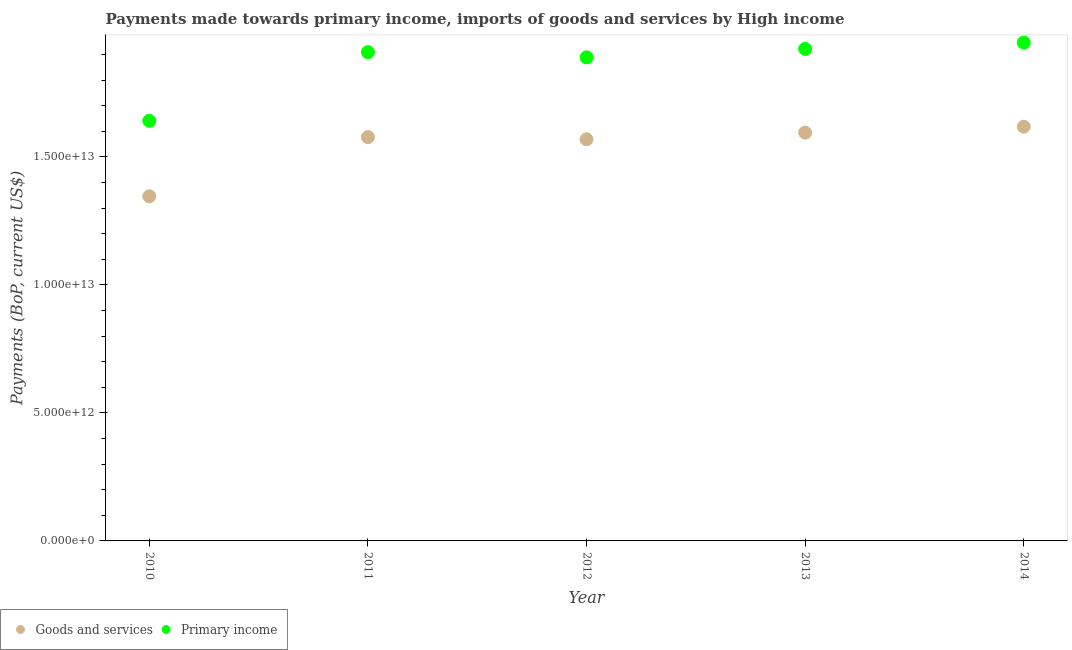How many different coloured dotlines are there?
Offer a terse response. 2. Is the number of dotlines equal to the number of legend labels?
Ensure brevity in your answer.  Yes. What is the payments made towards primary income in 2012?
Provide a short and direct response. 1.89e+13. Across all years, what is the maximum payments made towards goods and services?
Provide a succinct answer. 1.62e+13. Across all years, what is the minimum payments made towards primary income?
Provide a succinct answer. 1.64e+13. In which year was the payments made towards primary income minimum?
Provide a short and direct response. 2010. What is the total payments made towards goods and services in the graph?
Give a very brief answer. 7.70e+13. What is the difference between the payments made towards goods and services in 2012 and that in 2013?
Provide a short and direct response. -2.59e+11. What is the difference between the payments made towards goods and services in 2011 and the payments made towards primary income in 2010?
Make the answer very short. -6.37e+11. What is the average payments made towards goods and services per year?
Make the answer very short. 1.54e+13. In the year 2010, what is the difference between the payments made towards primary income and payments made towards goods and services?
Provide a short and direct response. 2.95e+12. In how many years, is the payments made towards primary income greater than 5000000000000 US$?
Give a very brief answer. 5. What is the ratio of the payments made towards goods and services in 2011 to that in 2013?
Provide a short and direct response. 0.99. Is the payments made towards primary income in 2010 less than that in 2014?
Your response must be concise. Yes. What is the difference between the highest and the second highest payments made towards goods and services?
Keep it short and to the point. 2.32e+11. What is the difference between the highest and the lowest payments made towards goods and services?
Your answer should be compact. 2.72e+12. In how many years, is the payments made towards goods and services greater than the average payments made towards goods and services taken over all years?
Provide a succinct answer. 4. Is the sum of the payments made towards goods and services in 2010 and 2012 greater than the maximum payments made towards primary income across all years?
Provide a succinct answer. Yes. Is the payments made towards primary income strictly greater than the payments made towards goods and services over the years?
Your answer should be very brief. Yes. Is the payments made towards primary income strictly less than the payments made towards goods and services over the years?
Offer a terse response. No. How many dotlines are there?
Provide a short and direct response. 2. How many years are there in the graph?
Your answer should be compact. 5. What is the difference between two consecutive major ticks on the Y-axis?
Your answer should be compact. 5.00e+12. Does the graph contain any zero values?
Offer a very short reply. No. Where does the legend appear in the graph?
Keep it short and to the point. Bottom left. How are the legend labels stacked?
Your answer should be very brief. Horizontal. What is the title of the graph?
Provide a succinct answer. Payments made towards primary income, imports of goods and services by High income. Does "Death rate" appear as one of the legend labels in the graph?
Give a very brief answer. No. What is the label or title of the Y-axis?
Offer a very short reply. Payments (BoP, current US$). What is the Payments (BoP, current US$) in Goods and services in 2010?
Your answer should be very brief. 1.35e+13. What is the Payments (BoP, current US$) of Primary income in 2010?
Make the answer very short. 1.64e+13. What is the Payments (BoP, current US$) of Goods and services in 2011?
Your answer should be very brief. 1.58e+13. What is the Payments (BoP, current US$) in Primary income in 2011?
Provide a succinct answer. 1.91e+13. What is the Payments (BoP, current US$) of Goods and services in 2012?
Ensure brevity in your answer.  1.57e+13. What is the Payments (BoP, current US$) of Primary income in 2012?
Your answer should be compact. 1.89e+13. What is the Payments (BoP, current US$) in Goods and services in 2013?
Make the answer very short. 1.59e+13. What is the Payments (BoP, current US$) of Primary income in 2013?
Your response must be concise. 1.92e+13. What is the Payments (BoP, current US$) of Goods and services in 2014?
Provide a short and direct response. 1.62e+13. What is the Payments (BoP, current US$) of Primary income in 2014?
Your answer should be compact. 1.95e+13. Across all years, what is the maximum Payments (BoP, current US$) of Goods and services?
Provide a short and direct response. 1.62e+13. Across all years, what is the maximum Payments (BoP, current US$) in Primary income?
Your answer should be very brief. 1.95e+13. Across all years, what is the minimum Payments (BoP, current US$) in Goods and services?
Give a very brief answer. 1.35e+13. Across all years, what is the minimum Payments (BoP, current US$) in Primary income?
Your answer should be compact. 1.64e+13. What is the total Payments (BoP, current US$) of Goods and services in the graph?
Give a very brief answer. 7.70e+13. What is the total Payments (BoP, current US$) of Primary income in the graph?
Keep it short and to the point. 9.31e+13. What is the difference between the Payments (BoP, current US$) in Goods and services in 2010 and that in 2011?
Make the answer very short. -2.31e+12. What is the difference between the Payments (BoP, current US$) of Primary income in 2010 and that in 2011?
Give a very brief answer. -2.68e+12. What is the difference between the Payments (BoP, current US$) of Goods and services in 2010 and that in 2012?
Offer a terse response. -2.23e+12. What is the difference between the Payments (BoP, current US$) of Primary income in 2010 and that in 2012?
Ensure brevity in your answer.  -2.48e+12. What is the difference between the Payments (BoP, current US$) in Goods and services in 2010 and that in 2013?
Your answer should be compact. -2.49e+12. What is the difference between the Payments (BoP, current US$) in Primary income in 2010 and that in 2013?
Your answer should be compact. -2.81e+12. What is the difference between the Payments (BoP, current US$) in Goods and services in 2010 and that in 2014?
Provide a succinct answer. -2.72e+12. What is the difference between the Payments (BoP, current US$) of Primary income in 2010 and that in 2014?
Offer a terse response. -3.06e+12. What is the difference between the Payments (BoP, current US$) in Goods and services in 2011 and that in 2012?
Make the answer very short. 8.41e+1. What is the difference between the Payments (BoP, current US$) in Primary income in 2011 and that in 2012?
Provide a succinct answer. 2.03e+11. What is the difference between the Payments (BoP, current US$) in Goods and services in 2011 and that in 2013?
Ensure brevity in your answer.  -1.75e+11. What is the difference between the Payments (BoP, current US$) in Primary income in 2011 and that in 2013?
Make the answer very short. -1.29e+11. What is the difference between the Payments (BoP, current US$) in Goods and services in 2011 and that in 2014?
Provide a succinct answer. -4.07e+11. What is the difference between the Payments (BoP, current US$) of Primary income in 2011 and that in 2014?
Your response must be concise. -3.76e+11. What is the difference between the Payments (BoP, current US$) of Goods and services in 2012 and that in 2013?
Your answer should be compact. -2.59e+11. What is the difference between the Payments (BoP, current US$) in Primary income in 2012 and that in 2013?
Offer a very short reply. -3.32e+11. What is the difference between the Payments (BoP, current US$) of Goods and services in 2012 and that in 2014?
Provide a succinct answer. -4.91e+11. What is the difference between the Payments (BoP, current US$) of Primary income in 2012 and that in 2014?
Make the answer very short. -5.79e+11. What is the difference between the Payments (BoP, current US$) of Goods and services in 2013 and that in 2014?
Your response must be concise. -2.32e+11. What is the difference between the Payments (BoP, current US$) of Primary income in 2013 and that in 2014?
Offer a terse response. -2.47e+11. What is the difference between the Payments (BoP, current US$) of Goods and services in 2010 and the Payments (BoP, current US$) of Primary income in 2011?
Keep it short and to the point. -5.63e+12. What is the difference between the Payments (BoP, current US$) of Goods and services in 2010 and the Payments (BoP, current US$) of Primary income in 2012?
Keep it short and to the point. -5.42e+12. What is the difference between the Payments (BoP, current US$) in Goods and services in 2010 and the Payments (BoP, current US$) in Primary income in 2013?
Make the answer very short. -5.76e+12. What is the difference between the Payments (BoP, current US$) of Goods and services in 2010 and the Payments (BoP, current US$) of Primary income in 2014?
Ensure brevity in your answer.  -6.00e+12. What is the difference between the Payments (BoP, current US$) in Goods and services in 2011 and the Payments (BoP, current US$) in Primary income in 2012?
Offer a very short reply. -3.11e+12. What is the difference between the Payments (BoP, current US$) of Goods and services in 2011 and the Payments (BoP, current US$) of Primary income in 2013?
Provide a short and direct response. -3.45e+12. What is the difference between the Payments (BoP, current US$) of Goods and services in 2011 and the Payments (BoP, current US$) of Primary income in 2014?
Keep it short and to the point. -3.69e+12. What is the difference between the Payments (BoP, current US$) of Goods and services in 2012 and the Payments (BoP, current US$) of Primary income in 2013?
Your answer should be very brief. -3.53e+12. What is the difference between the Payments (BoP, current US$) of Goods and services in 2012 and the Payments (BoP, current US$) of Primary income in 2014?
Provide a succinct answer. -3.78e+12. What is the difference between the Payments (BoP, current US$) of Goods and services in 2013 and the Payments (BoP, current US$) of Primary income in 2014?
Keep it short and to the point. -3.52e+12. What is the average Payments (BoP, current US$) of Goods and services per year?
Make the answer very short. 1.54e+13. What is the average Payments (BoP, current US$) of Primary income per year?
Keep it short and to the point. 1.86e+13. In the year 2010, what is the difference between the Payments (BoP, current US$) in Goods and services and Payments (BoP, current US$) in Primary income?
Give a very brief answer. -2.95e+12. In the year 2011, what is the difference between the Payments (BoP, current US$) of Goods and services and Payments (BoP, current US$) of Primary income?
Your answer should be compact. -3.32e+12. In the year 2012, what is the difference between the Payments (BoP, current US$) of Goods and services and Payments (BoP, current US$) of Primary income?
Provide a succinct answer. -3.20e+12. In the year 2013, what is the difference between the Payments (BoP, current US$) in Goods and services and Payments (BoP, current US$) in Primary income?
Give a very brief answer. -3.27e+12. In the year 2014, what is the difference between the Payments (BoP, current US$) in Goods and services and Payments (BoP, current US$) in Primary income?
Keep it short and to the point. -3.29e+12. What is the ratio of the Payments (BoP, current US$) of Goods and services in 2010 to that in 2011?
Keep it short and to the point. 0.85. What is the ratio of the Payments (BoP, current US$) in Primary income in 2010 to that in 2011?
Offer a very short reply. 0.86. What is the ratio of the Payments (BoP, current US$) of Goods and services in 2010 to that in 2012?
Your answer should be very brief. 0.86. What is the ratio of the Payments (BoP, current US$) in Primary income in 2010 to that in 2012?
Provide a succinct answer. 0.87. What is the ratio of the Payments (BoP, current US$) in Goods and services in 2010 to that in 2013?
Give a very brief answer. 0.84. What is the ratio of the Payments (BoP, current US$) of Primary income in 2010 to that in 2013?
Ensure brevity in your answer.  0.85. What is the ratio of the Payments (BoP, current US$) in Goods and services in 2010 to that in 2014?
Your answer should be compact. 0.83. What is the ratio of the Payments (BoP, current US$) in Primary income in 2010 to that in 2014?
Give a very brief answer. 0.84. What is the ratio of the Payments (BoP, current US$) of Goods and services in 2011 to that in 2012?
Offer a very short reply. 1.01. What is the ratio of the Payments (BoP, current US$) in Primary income in 2011 to that in 2012?
Ensure brevity in your answer.  1.01. What is the ratio of the Payments (BoP, current US$) of Primary income in 2011 to that in 2013?
Provide a short and direct response. 0.99. What is the ratio of the Payments (BoP, current US$) in Goods and services in 2011 to that in 2014?
Keep it short and to the point. 0.97. What is the ratio of the Payments (BoP, current US$) in Primary income in 2011 to that in 2014?
Give a very brief answer. 0.98. What is the ratio of the Payments (BoP, current US$) in Goods and services in 2012 to that in 2013?
Offer a very short reply. 0.98. What is the ratio of the Payments (BoP, current US$) of Primary income in 2012 to that in 2013?
Offer a very short reply. 0.98. What is the ratio of the Payments (BoP, current US$) of Goods and services in 2012 to that in 2014?
Offer a terse response. 0.97. What is the ratio of the Payments (BoP, current US$) of Primary income in 2012 to that in 2014?
Give a very brief answer. 0.97. What is the ratio of the Payments (BoP, current US$) in Goods and services in 2013 to that in 2014?
Offer a very short reply. 0.99. What is the ratio of the Payments (BoP, current US$) of Primary income in 2013 to that in 2014?
Ensure brevity in your answer.  0.99. What is the difference between the highest and the second highest Payments (BoP, current US$) of Goods and services?
Keep it short and to the point. 2.32e+11. What is the difference between the highest and the second highest Payments (BoP, current US$) in Primary income?
Your answer should be very brief. 2.47e+11. What is the difference between the highest and the lowest Payments (BoP, current US$) in Goods and services?
Ensure brevity in your answer.  2.72e+12. What is the difference between the highest and the lowest Payments (BoP, current US$) in Primary income?
Your response must be concise. 3.06e+12. 